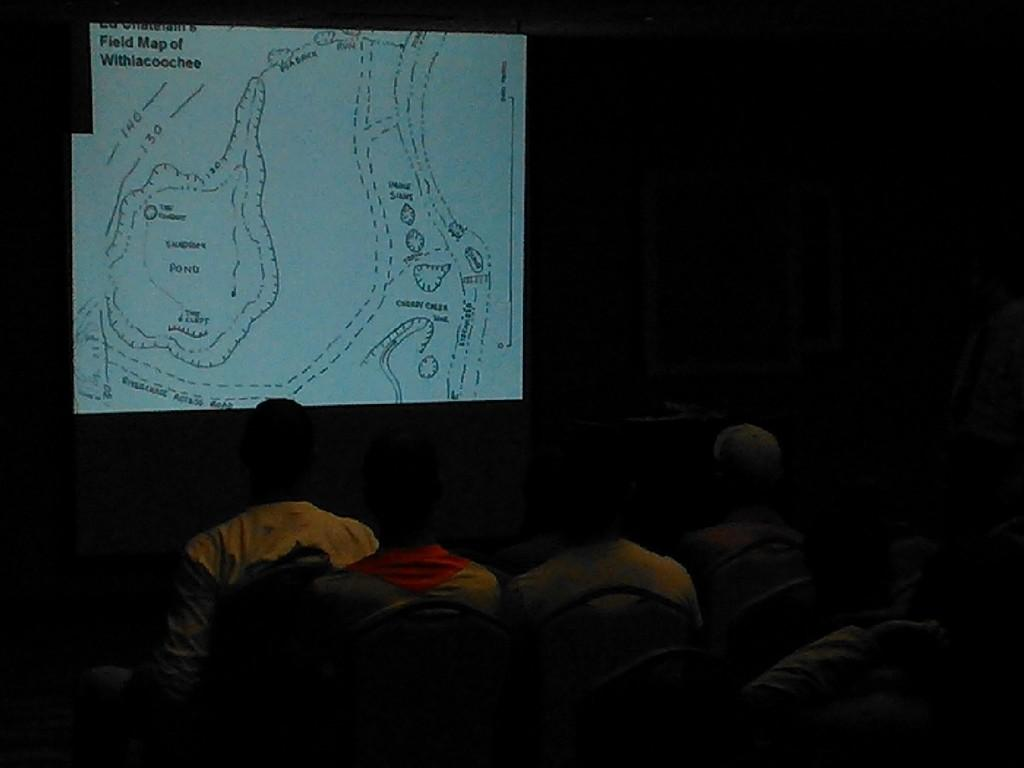What are the people in the image doing? The people in the image are sitting on chairs. Where are the chairs located in the image? The chairs are in the center of the image. What can be seen in the background of the image? There is a screen in the background of the image. What is displayed on the screen? Text and drawings are visible on the screen. What type of metal is used to make the elbow of the person sitting on the chair? There is no mention of a person's elbow or any metal in the image, so it cannot be determined. How many birds are visible on the screen in the image? There are no birds visible on the screen or in the image. 